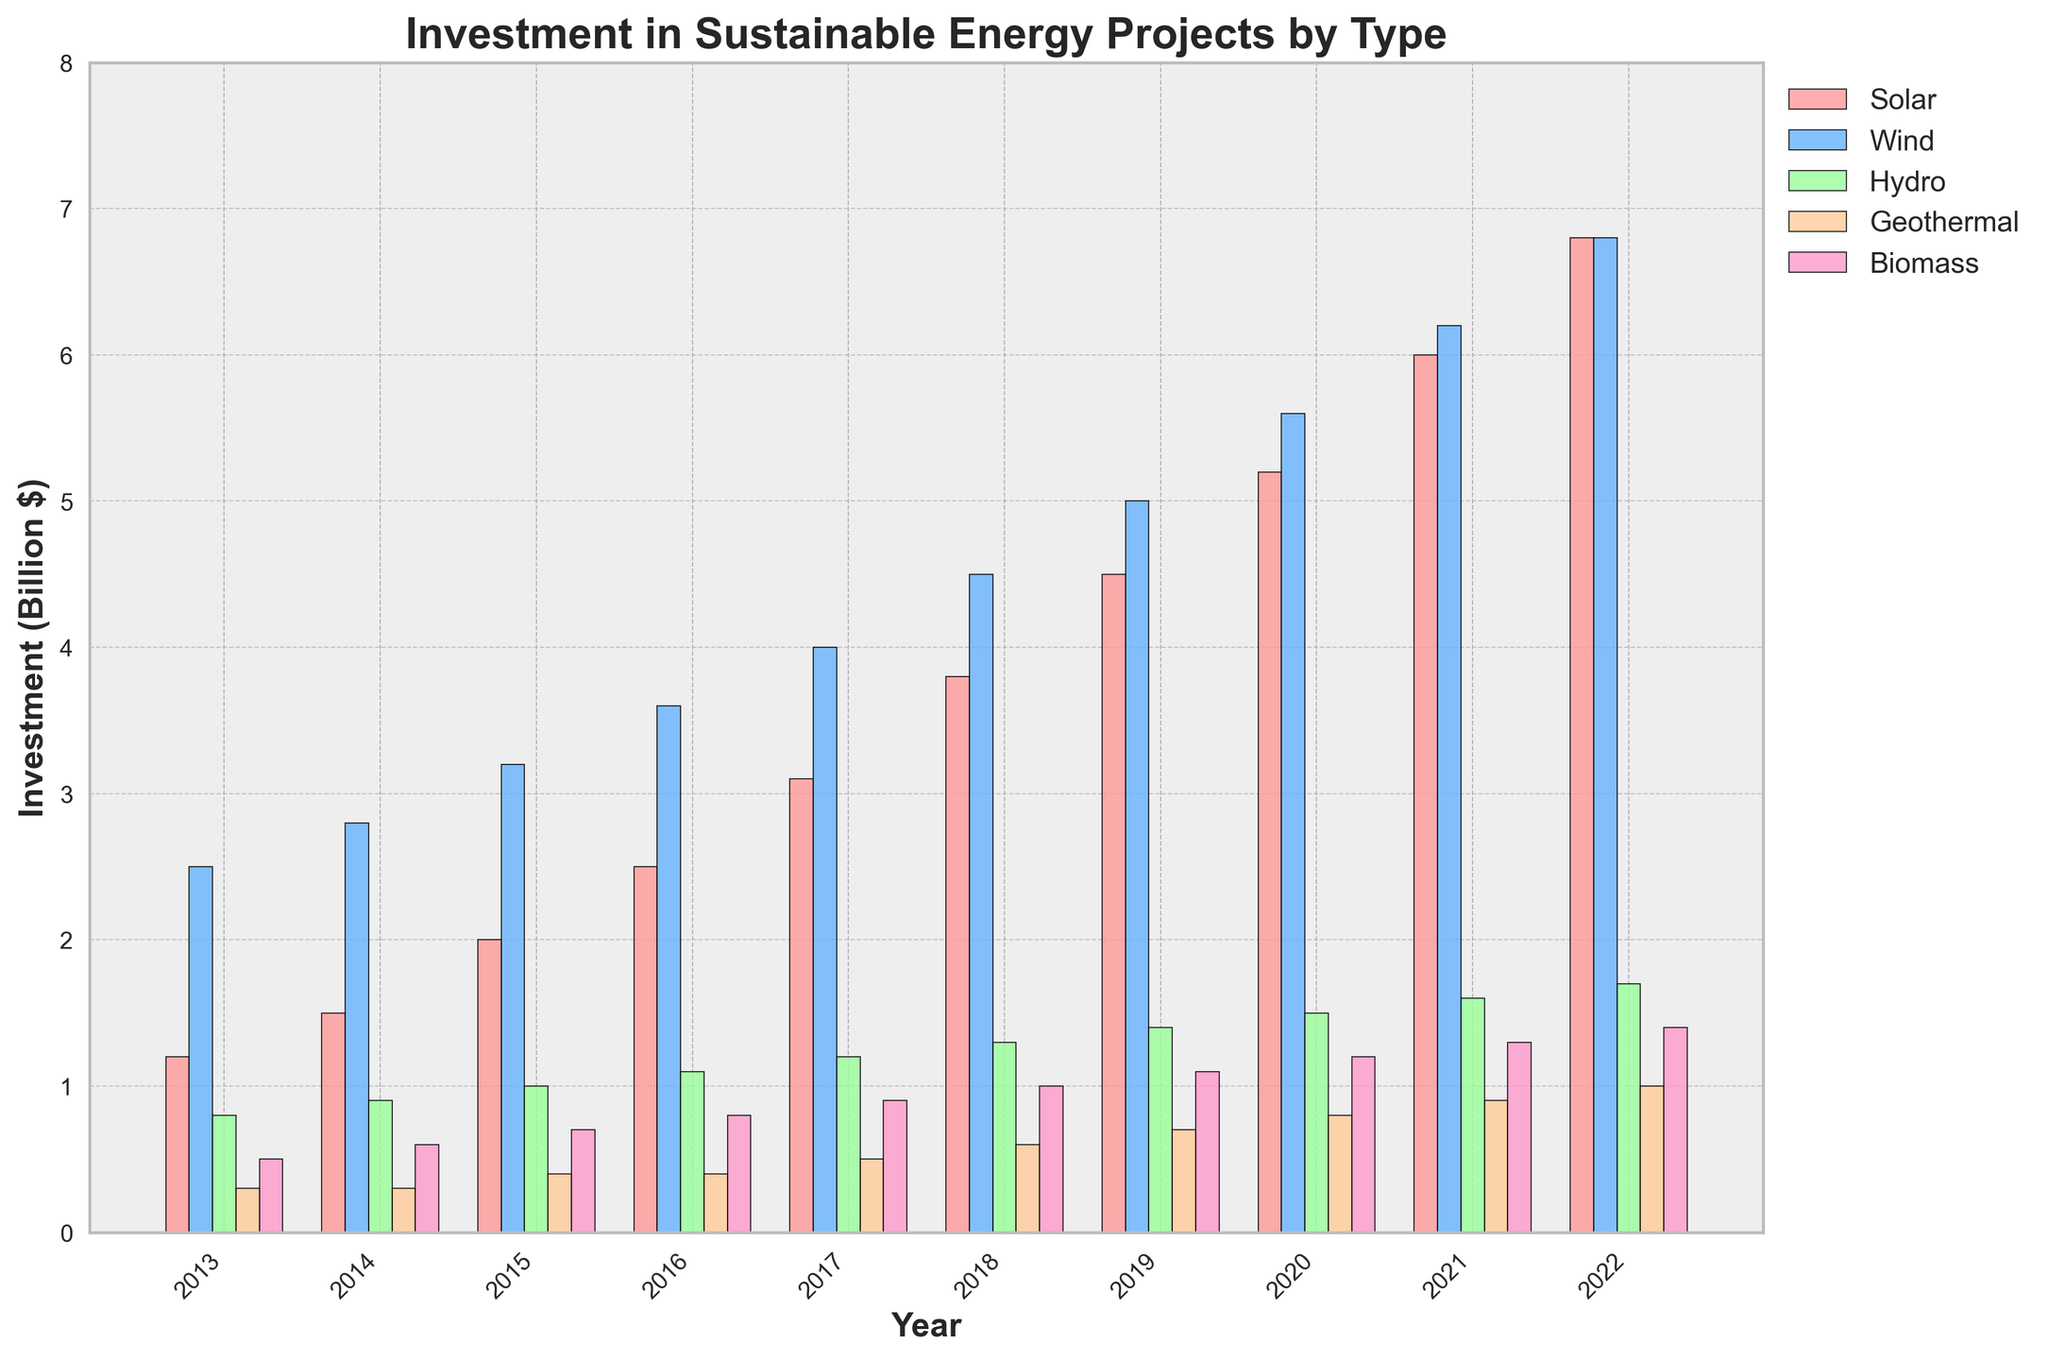What's the total investment in solar energy from 2013 to 2022? To find the total investment in solar energy over the decade, sum the values from each year: 1.2 + 1.5 + 2.0 + 2.5 + 3.1 + 3.8 + 4.5 + 5.2 + 6.0 + 6.8 = 36.6 billion dollars
Answer: 36.6 billion dollars Which energy type received the highest investment in 2022? By looking at the heights of the bars for 2022, the wind energy bar is equal in height to the solar energy bar. Both received the highest investment of 6.8 billion dollars
Answer: Wind & Solar How did the investment in biomass energy change from 2013 to 2022? The investment in biomass energy in 2013 was 0.5 billion dollars and increased each year, reaching 1.4 billion dollars in 2022. To find the change: 1.4 - 0.5 = 0.9 billion dollars
Answer: Increased by 0.9 billion dollars Which energy type had the largest growth in investment from 2013 to 2022? To find the largest growth, calculate the difference between 2022 and 2013 for each energy type: Solar (6.8 - 1.2 = 5.6), Wind (6.8 - 2.5 = 4.3), Hydro (1.7 - 0.8 = 0.9), Geothermal (1.0 - 0.3 = 0.7), Biomass (1.4 - 0.5 = 0.9). Solar had the largest growth of 5.6 billion dollars
Answer: Solar Across all years, which energy type consistently grew every year? By examining the trends for each energy type, solar energy shows a continuous year-on-year increase from 2013 to 2022 without decline
Answer: Solar In which year did the investment in wind energy surpass solar energy? Observing the bars for wind and solar energy, wind energy always had higher investments except in 2022 where they were equal. Therefore, wind energy has been above solar energy continuously up to 2022
Answer: Before 2022 Which two years showed the highest increase in total investment across all energy types? To find this, calculate the total investment for each year and then the yearly difference: 
2013 = 5.3, 2014 = 6.1, 2015 = 7.3, 2016 = 8.4, 2017 = 9.7, 2018 = 11.2, 2019 = 12.7, 2020 = 14.3, 2021 = 16.0, 2022 = 17.7. The largest increases were from 2020 to 2021 (16.0 - 14.3 = 1.7) and 2018 to 2019 (12.7 - 11.2 = 1.5)
Answer: 2020 to 2021 & 2018 to 2019 What's the average annual investment in hydro energy over this decade? To find the average, sum the hydro values and divide by 10. Sum: 0.8 + 0.9 + 1.0 + 1.1 + 1.2 + 1.3 + 1.4 + 1.5 + 1.6 + 1.7 = 12.5. Average: 12.5 / 10 = 1.25 billion dollars
Answer: 1.25 billion dollars Between 2015 and 2017, which energy type saw the greatest increase in investment? Calculate the increase for each energy type between 2015 and 2017: Solar (3.1 - 2.0 = 1.1), Wind (4.0 - 3.2 = 0.8), Hydro (1.2 - 1.0 = 0.2), Geothermal (0.5 - 0.4 = 0.1), Biomass (0.9 - 0.7 = 0.2). Solar energy saw the greatest increase of 1.1 billion dollars
Answer: Solar 